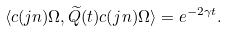<formula> <loc_0><loc_0><loc_500><loc_500>\langle c ( j n ) \Omega , \widetilde { Q } ( t ) c ( j n ) \Omega \rangle = e ^ { - 2 \gamma t } .</formula> 